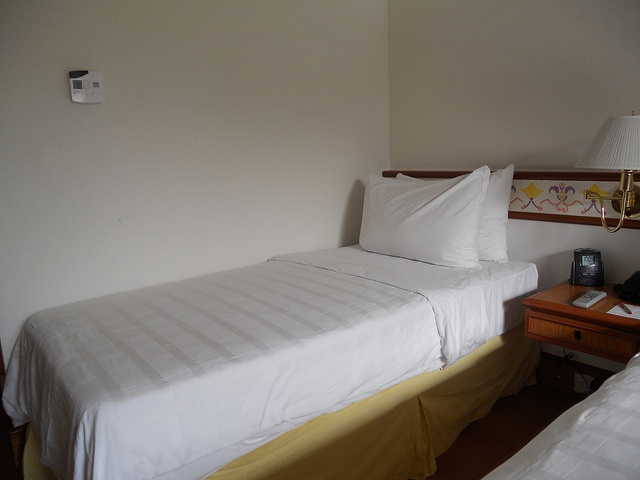Describe the objects in this image and their specific colors. I can see bed in gray, darkgray, and lightgray tones, bed in gray, darkgray, and black tones, clock in gray and black tones, and remote in gray and black tones in this image. 